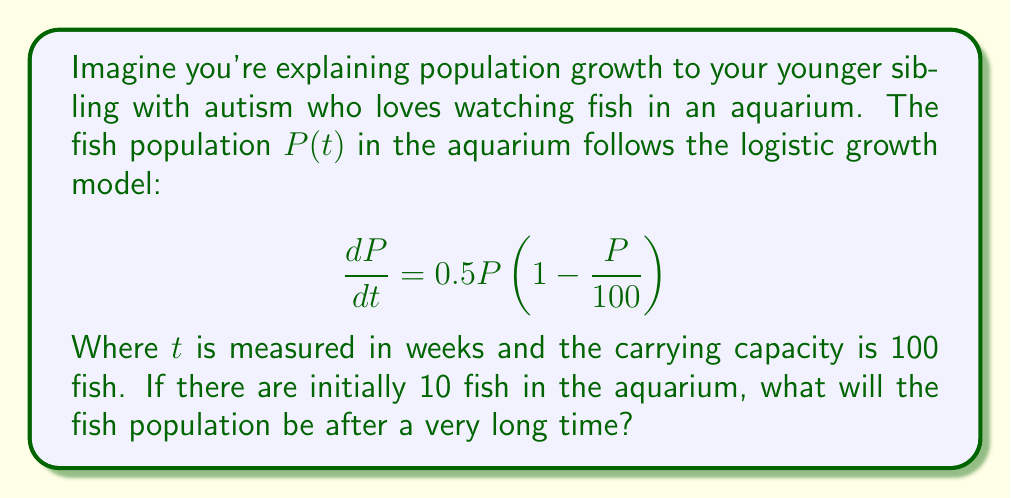Can you solve this math problem? Let's break this down step-by-step:

1) The given equation is a logistic growth model:
   $$\frac{dP}{dt} = rP\left(1 - \frac{P}{K}\right)$$
   Where:
   - $r = 0.5$ (growth rate)
   - $K = 100$ (carrying capacity)

2) To find the long-term behavior, we need to find the equilibrium points. These occur when $\frac{dP}{dt} = 0$.

3) Set the equation equal to zero:
   $$0 = 0.5P\left(1 - \frac{P}{100}\right)$$

4) Solve for P:
   - $P = 0$ (trivial solution)
   - Or: $1 - \frac{P}{100} = 0$
         $\frac{P}{100} = 1$
         $P = 100$

5) The non-zero equilibrium point $P = 100$ is stable and attracts all positive initial conditions.

6) Therefore, regardless of the initial population (as long as it's positive), the long-term population will approach the carrying capacity.

7) In this case, the carrying capacity is 100 fish.
Answer: 100 fish 